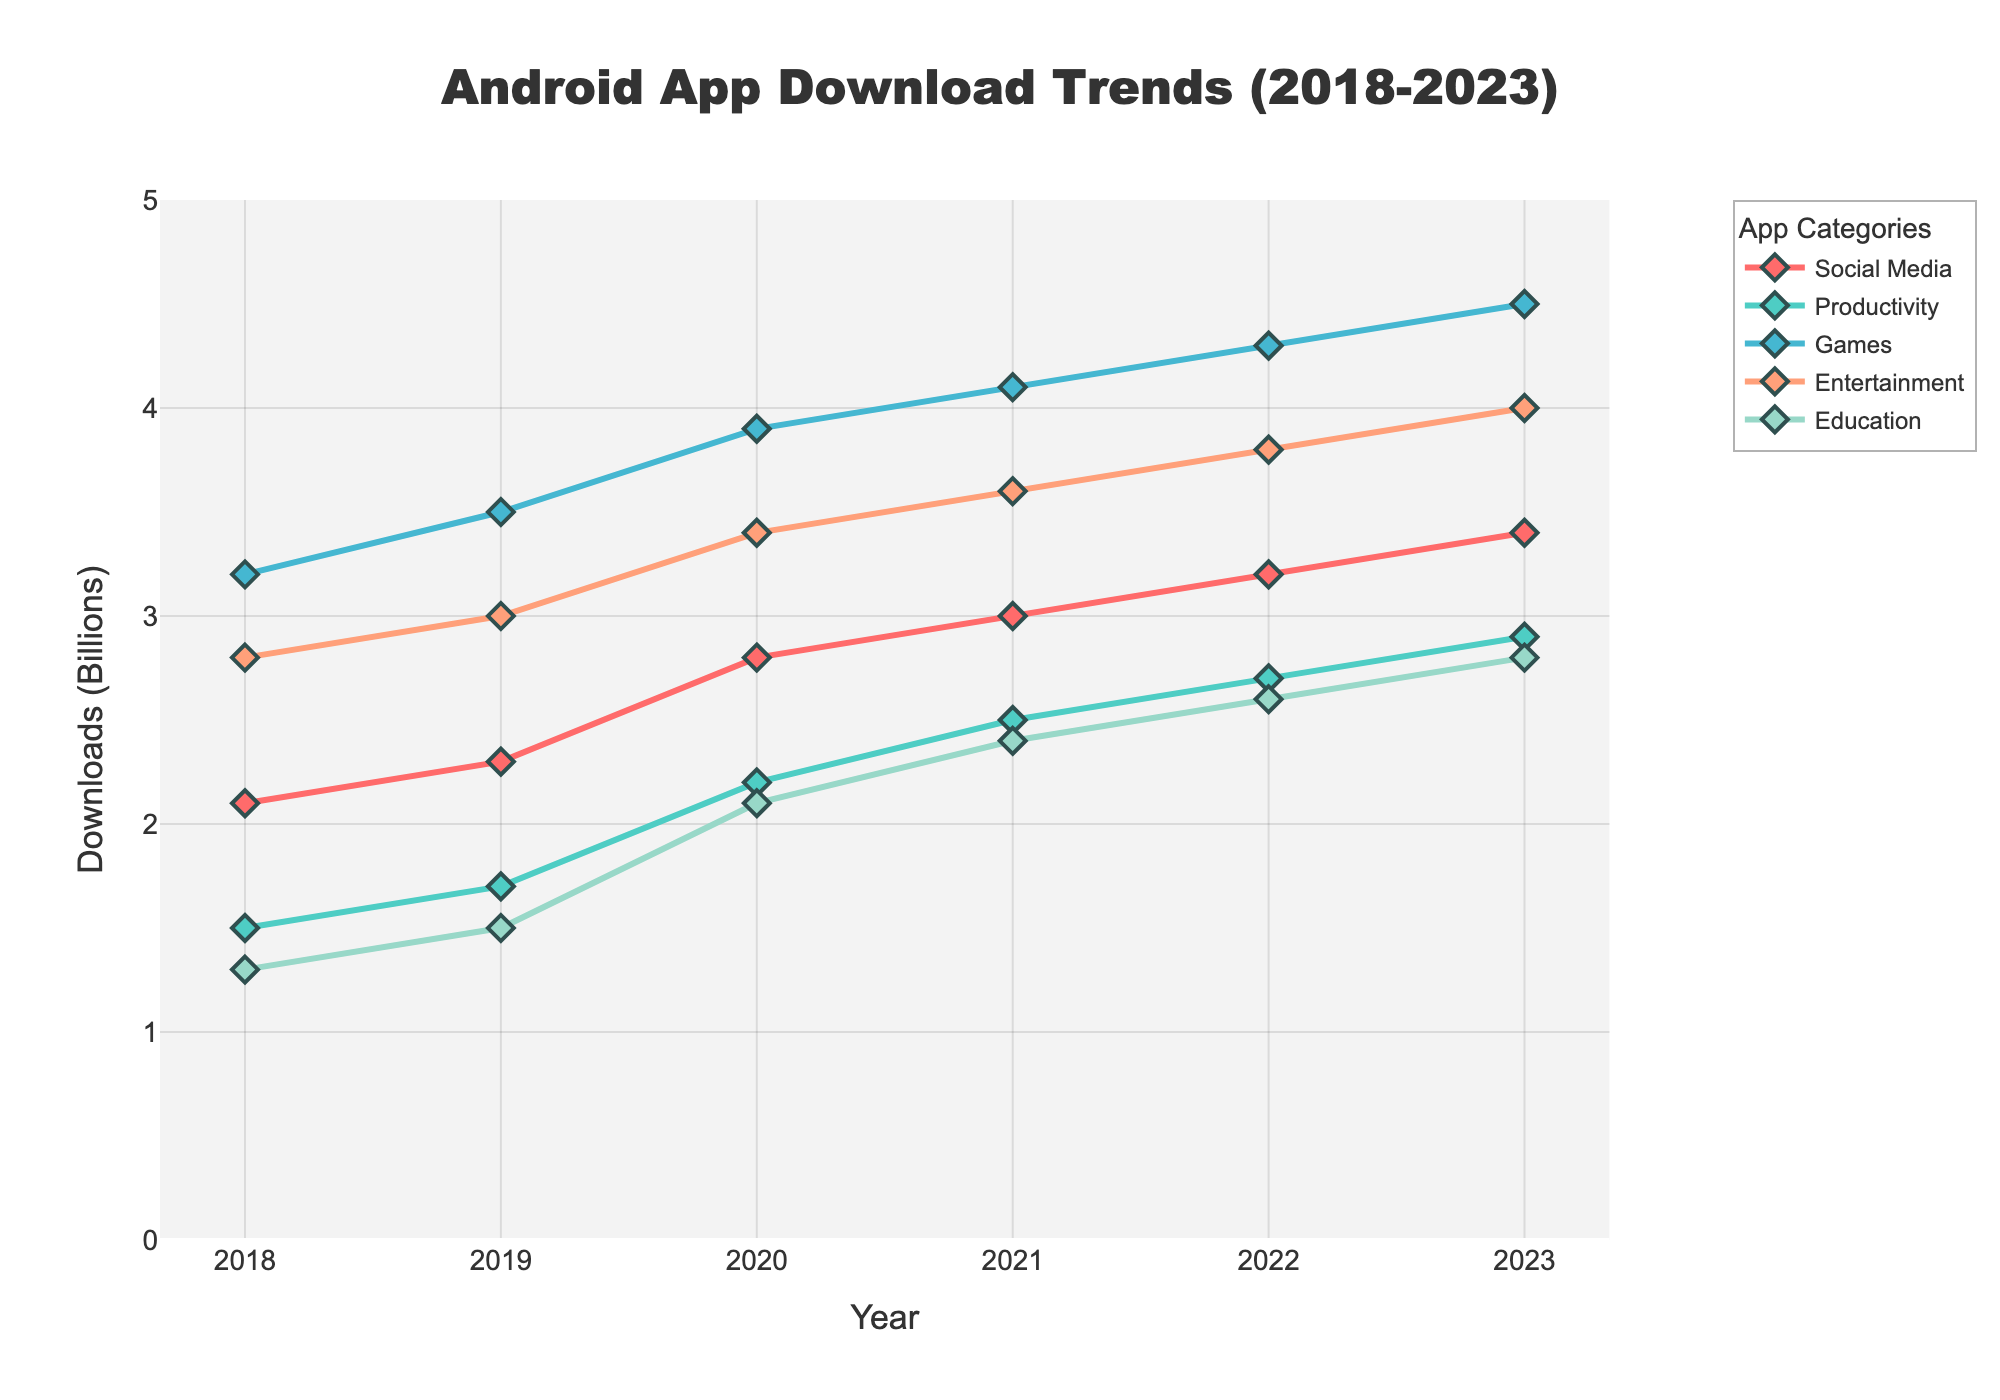Which app category had the highest number of downloads in 2023? According to the line chart, the 'Games' category had the highest number of downloads reaching 4.5 billion in 2023.
Answer: Games How many downloads did the Social Media category increase by from 2018 to 2023? In 2018, Social Media downloads were 2.1 billion, and in 2023, it was 3.4 billion. The increase is 3.4 - 2.1 = 1.3 billion.
Answer: 1.3 billion In which year did the Productivity category surpass 2.5 billion downloads? The Productivity category surpassed 2.5 billion downloads in 2021 according to the chart.
Answer: 2021 Which two app categories had the closest number of downloads in 2020? In 2020, Productivity had 2.2 billion downloads, and Education had 2.1 billion downloads. The difference is just 0.1 billion.
Answer: Productivity and Education Between 2022 and 2023, which app category showed the highest increase in downloads? From 2022 to 2023, the largest increase in downloads was in the Entertainment category, increasing from 3.8 billion to 4.0 billion, which is an increase of 0.2 billion.
Answer: Entertainment What is the cumulative number of downloads across all categories in 2019? The cumulative number of downloads in 2019 is the sum of downloads across all categories: 2.3 (Social Media) + 1.7 (Productivity) + 3.5 (Games) + 3.0 (Entertainment) + 1.5 (Education) = 12.0 billion.
Answer: 12.0 billion Which app category had the most consistent growth in downloads over the 5 years period? The chart shows that the Productivity category had the most consistent growth, with steady increases each year from 1.5 billion downloads in 2018 to 2.9 billion in 2023.
Answer: Productivity How did the download trends of Social Media compare to Entertainment from 2018 to 2023? Both categories showed an upward trend over the period. Social Media downloads increased from 2.1 billion to 3.4 billion, while Entertainment downloads increased from 2.8 billion to 4.0 billion. Both trends grew steadily with Entertainment usually staying ahead.
Answer: Both showed upward trends (Entertainment grew more) What is the average annual growth in downloads for the Games category from 2018 to 2023? Calculate the growth for each year and find the average: 
    - 2019: 3.5 - 3.2 = 0.3
    - 2020: 3.9 - 3.5 = 0.4
    - 2021: 4.1 - 3.9 = 0.2
    - 2022: 4.3 - 4.1 = 0.2
    - 2023: 4.5 - 4.3 = 0.2
Sum of growth rates: 0.3 + 0.4 + 0.2 + 0.2 + 0.2 = 1.3. Average growth: 1.3 / 5 = 0.26 billion per year.
Answer: 0.26 billion per year Which app category had the steepest year-on-year increase in any given year? In 2020, the Education category increased from 1.5 billion in 2019 to 2.1 billion, an increase of 0.6 billion, which is the steepest year-on-year increase for any category.
Answer: Education in 2020 